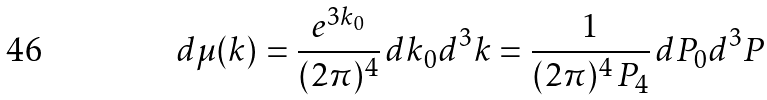<formula> <loc_0><loc_0><loc_500><loc_500>d \mu ( k ) = \frac { e ^ { 3 k _ { 0 } } } { ( 2 \pi ) ^ { 4 } } \, d k _ { 0 } d ^ { 3 } k = \frac { 1 } { ( 2 \pi ) ^ { 4 } \, P _ { 4 } } \, d P _ { 0 } d ^ { 3 } P</formula> 